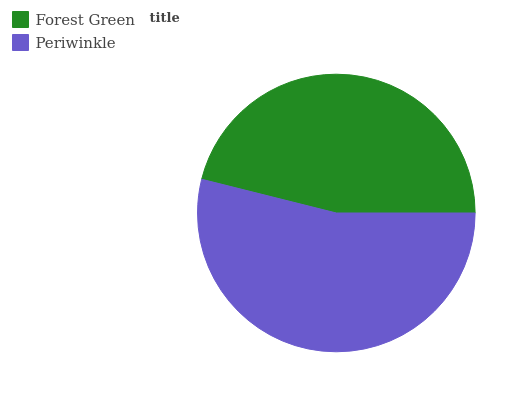Is Forest Green the minimum?
Answer yes or no. Yes. Is Periwinkle the maximum?
Answer yes or no. Yes. Is Periwinkle the minimum?
Answer yes or no. No. Is Periwinkle greater than Forest Green?
Answer yes or no. Yes. Is Forest Green less than Periwinkle?
Answer yes or no. Yes. Is Forest Green greater than Periwinkle?
Answer yes or no. No. Is Periwinkle less than Forest Green?
Answer yes or no. No. Is Periwinkle the high median?
Answer yes or no. Yes. Is Forest Green the low median?
Answer yes or no. Yes. Is Forest Green the high median?
Answer yes or no. No. Is Periwinkle the low median?
Answer yes or no. No. 